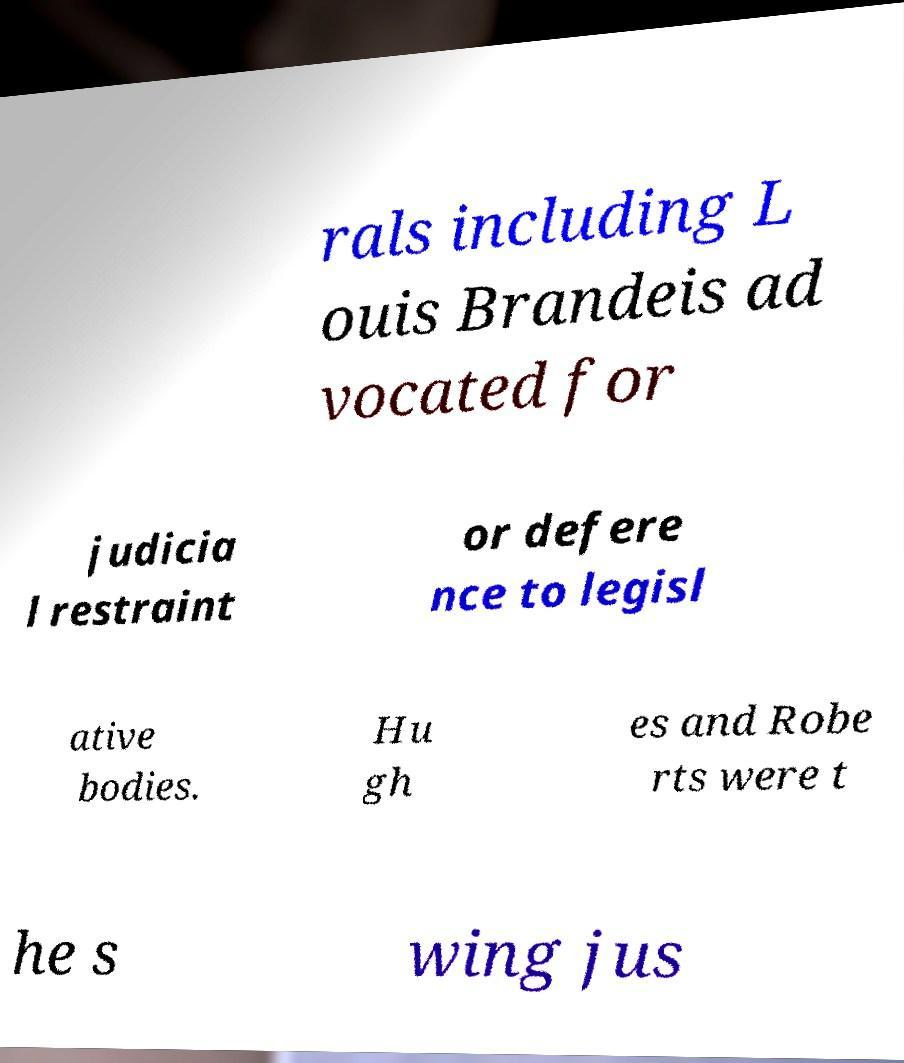I need the written content from this picture converted into text. Can you do that? rals including L ouis Brandeis ad vocated for judicia l restraint or defere nce to legisl ative bodies. Hu gh es and Robe rts were t he s wing jus 